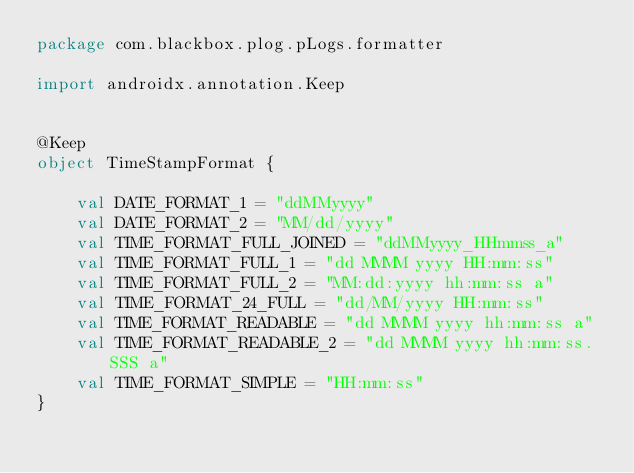<code> <loc_0><loc_0><loc_500><loc_500><_Kotlin_>package com.blackbox.plog.pLogs.formatter

import androidx.annotation.Keep


@Keep
object TimeStampFormat {

    val DATE_FORMAT_1 = "ddMMyyyy"
    val DATE_FORMAT_2 = "MM/dd/yyyy"
    val TIME_FORMAT_FULL_JOINED = "ddMMyyyy_HHmmss_a"
    val TIME_FORMAT_FULL_1 = "dd MMMM yyyy HH:mm:ss"
    val TIME_FORMAT_FULL_2 = "MM:dd:yyyy hh:mm:ss a"
    val TIME_FORMAT_24_FULL = "dd/MM/yyyy HH:mm:ss"
    val TIME_FORMAT_READABLE = "dd MMMM yyyy hh:mm:ss a"
    val TIME_FORMAT_READABLE_2 = "dd MMMM yyyy hh:mm:ss.SSS a"
    val TIME_FORMAT_SIMPLE = "HH:mm:ss"
}</code> 